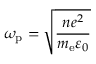<formula> <loc_0><loc_0><loc_500><loc_500>\omega _ { p } = \sqrt { \frac { n e ^ { 2 } } { m _ { e } \varepsilon _ { 0 } } }</formula> 